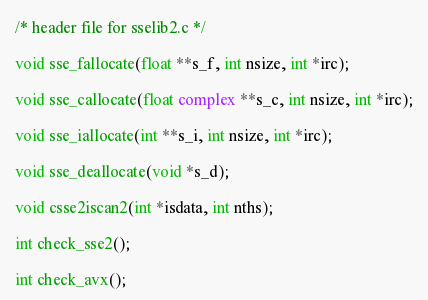<code> <loc_0><loc_0><loc_500><loc_500><_C_>/* header file for sselib2.c */

void sse_fallocate(float **s_f, int nsize, int *irc);

void sse_callocate(float complex **s_c, int nsize, int *irc);

void sse_iallocate(int **s_i, int nsize, int *irc);

void sse_deallocate(void *s_d);

void csse2iscan2(int *isdata, int nths);

int check_sse2();

int check_avx();

</code> 